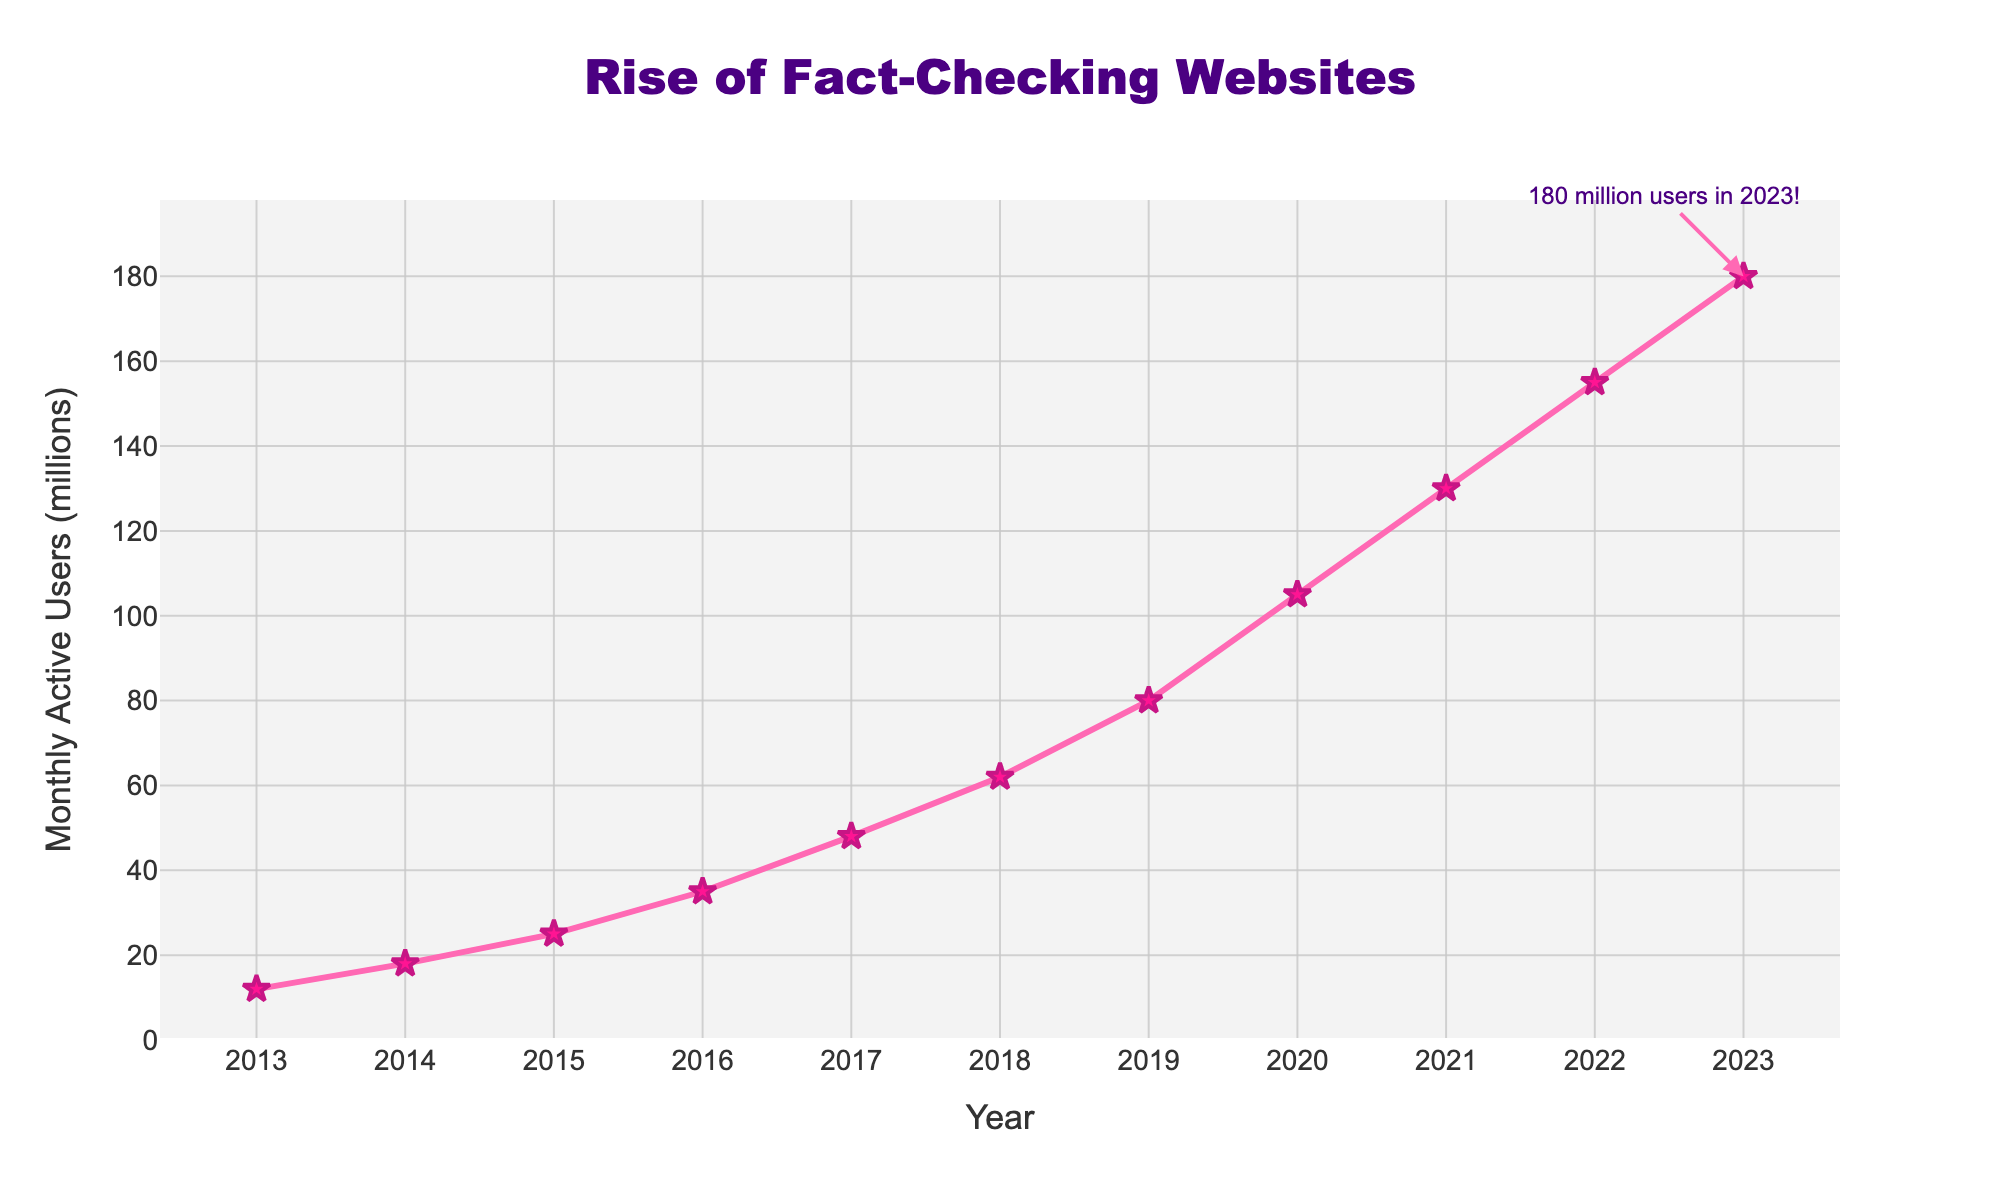What year had the highest increase in monthly active users compared to the previous year? The highest increase is calculated by comparing the users year by year. The difference between 2020 and 2021 is the largest, with an increase from 105 million to 130 million, a 25 million increase.
Answer: 2021 How many millions of users were gained from 2018 to 2020? To find the gain from 2018 to 2020, subtract the number of users in 2018 from the number of users in 2020: 105 - 62 = 43 million.
Answer: 43 million Which year had the smallest increase in monthly active users compared to the previous year? The smallest increase is found by comparing year-to-year differences. The smallest increase is from 2014 to 2015, with an increase from 18 million to 25 million, a 7 million increase.
Answer: 2015 What’s the average number of monthly active users from 2013 to 2023? Sum the users from each year and divide by the number of years: (12 + 18 + 25 + 35 + 48 + 62 + 80 + 105 + 130 + 155 + 180) / 11 = 77 million (rounded).
Answer: 77 million Which year first crossed the threshold of 100 million monthly active users? By checking the data, 2020 is the first year when the number of monthly active users reached 105 million, crossing the 100 million mark.
Answer: 2020 What's the trend of the line chart from 2013 to 2023? The trend shows a consistent increase in the number of monthly active users year by year, with no decrease or plateau.
Answer: Increasing By how many times did the monthly active users increase from 2013 to 2023? Calculate the factor by dividing the 2023 number by the 2013 number: 180 / 12 = 15.
Answer: 15 times In which year did the number of monthly active users exceed double its value from two years prior? Comparing the users in each year with two years prior, 2015 (25 million) is more than double the value of 2013 (12 million).
Answer: 2015 How does the color of the markers and line in the figure contribute to the aesthetics of the chart? The markers and line are a bright pink which stands out against the background and enhances visual appeal, making the data points prominent and visually engaging.
Answer: Enhances clarity and appeal 